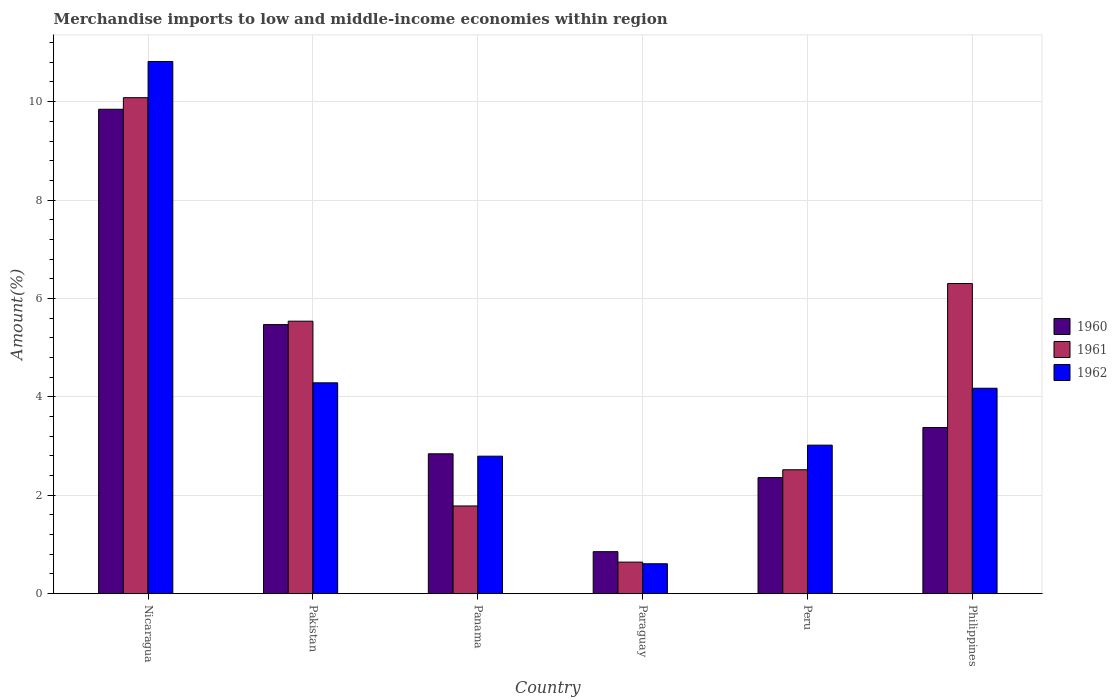How many groups of bars are there?
Your answer should be compact. 6. Are the number of bars per tick equal to the number of legend labels?
Give a very brief answer. Yes. How many bars are there on the 5th tick from the right?
Provide a short and direct response. 3. What is the label of the 2nd group of bars from the left?
Your answer should be compact. Pakistan. In how many cases, is the number of bars for a given country not equal to the number of legend labels?
Your response must be concise. 0. What is the percentage of amount earned from merchandise imports in 1961 in Peru?
Provide a succinct answer. 2.52. Across all countries, what is the maximum percentage of amount earned from merchandise imports in 1962?
Offer a terse response. 10.82. Across all countries, what is the minimum percentage of amount earned from merchandise imports in 1962?
Provide a succinct answer. 0.61. In which country was the percentage of amount earned from merchandise imports in 1961 maximum?
Ensure brevity in your answer.  Nicaragua. In which country was the percentage of amount earned from merchandise imports in 1960 minimum?
Give a very brief answer. Paraguay. What is the total percentage of amount earned from merchandise imports in 1960 in the graph?
Provide a short and direct response. 24.75. What is the difference between the percentage of amount earned from merchandise imports in 1962 in Panama and that in Paraguay?
Offer a terse response. 2.19. What is the difference between the percentage of amount earned from merchandise imports in 1962 in Peru and the percentage of amount earned from merchandise imports in 1961 in Paraguay?
Offer a very short reply. 2.38. What is the average percentage of amount earned from merchandise imports in 1962 per country?
Offer a very short reply. 4.28. What is the difference between the percentage of amount earned from merchandise imports of/in 1962 and percentage of amount earned from merchandise imports of/in 1961 in Nicaragua?
Your answer should be compact. 0.74. In how many countries, is the percentage of amount earned from merchandise imports in 1961 greater than 8.4 %?
Your answer should be very brief. 1. What is the ratio of the percentage of amount earned from merchandise imports in 1961 in Pakistan to that in Panama?
Provide a short and direct response. 3.11. Is the percentage of amount earned from merchandise imports in 1962 in Panama less than that in Peru?
Provide a short and direct response. Yes. What is the difference between the highest and the second highest percentage of amount earned from merchandise imports in 1961?
Provide a short and direct response. 4.54. What is the difference between the highest and the lowest percentage of amount earned from merchandise imports in 1961?
Keep it short and to the point. 9.44. In how many countries, is the percentage of amount earned from merchandise imports in 1960 greater than the average percentage of amount earned from merchandise imports in 1960 taken over all countries?
Keep it short and to the point. 2. Is the sum of the percentage of amount earned from merchandise imports in 1960 in Peru and Philippines greater than the maximum percentage of amount earned from merchandise imports in 1962 across all countries?
Offer a very short reply. No. What does the 1st bar from the right in Paraguay represents?
Your answer should be very brief. 1962. Is it the case that in every country, the sum of the percentage of amount earned from merchandise imports in 1961 and percentage of amount earned from merchandise imports in 1962 is greater than the percentage of amount earned from merchandise imports in 1960?
Offer a terse response. Yes. How many bars are there?
Your answer should be compact. 18. How many countries are there in the graph?
Keep it short and to the point. 6. What is the difference between two consecutive major ticks on the Y-axis?
Your answer should be very brief. 2. Are the values on the major ticks of Y-axis written in scientific E-notation?
Your response must be concise. No. Does the graph contain any zero values?
Provide a short and direct response. No. Does the graph contain grids?
Provide a short and direct response. Yes. Where does the legend appear in the graph?
Your answer should be compact. Center right. How many legend labels are there?
Provide a short and direct response. 3. How are the legend labels stacked?
Your response must be concise. Vertical. What is the title of the graph?
Ensure brevity in your answer.  Merchandise imports to low and middle-income economies within region. Does "1972" appear as one of the legend labels in the graph?
Your response must be concise. No. What is the label or title of the Y-axis?
Offer a terse response. Amount(%). What is the Amount(%) of 1960 in Nicaragua?
Provide a short and direct response. 9.85. What is the Amount(%) of 1961 in Nicaragua?
Offer a terse response. 10.08. What is the Amount(%) of 1962 in Nicaragua?
Your response must be concise. 10.82. What is the Amount(%) of 1960 in Pakistan?
Provide a succinct answer. 5.47. What is the Amount(%) of 1961 in Pakistan?
Ensure brevity in your answer.  5.54. What is the Amount(%) of 1962 in Pakistan?
Keep it short and to the point. 4.29. What is the Amount(%) of 1960 in Panama?
Your response must be concise. 2.84. What is the Amount(%) in 1961 in Panama?
Offer a very short reply. 1.78. What is the Amount(%) of 1962 in Panama?
Ensure brevity in your answer.  2.79. What is the Amount(%) in 1960 in Paraguay?
Keep it short and to the point. 0.85. What is the Amount(%) of 1961 in Paraguay?
Give a very brief answer. 0.64. What is the Amount(%) in 1962 in Paraguay?
Offer a terse response. 0.61. What is the Amount(%) of 1960 in Peru?
Offer a very short reply. 2.36. What is the Amount(%) in 1961 in Peru?
Ensure brevity in your answer.  2.52. What is the Amount(%) of 1962 in Peru?
Offer a very short reply. 3.02. What is the Amount(%) in 1960 in Philippines?
Provide a short and direct response. 3.38. What is the Amount(%) in 1961 in Philippines?
Ensure brevity in your answer.  6.3. What is the Amount(%) in 1962 in Philippines?
Make the answer very short. 4.18. Across all countries, what is the maximum Amount(%) of 1960?
Provide a short and direct response. 9.85. Across all countries, what is the maximum Amount(%) in 1961?
Provide a short and direct response. 10.08. Across all countries, what is the maximum Amount(%) in 1962?
Make the answer very short. 10.82. Across all countries, what is the minimum Amount(%) in 1960?
Ensure brevity in your answer.  0.85. Across all countries, what is the minimum Amount(%) in 1961?
Offer a very short reply. 0.64. Across all countries, what is the minimum Amount(%) in 1962?
Your answer should be very brief. 0.61. What is the total Amount(%) of 1960 in the graph?
Keep it short and to the point. 24.75. What is the total Amount(%) in 1961 in the graph?
Your answer should be very brief. 26.86. What is the total Amount(%) in 1962 in the graph?
Your response must be concise. 25.7. What is the difference between the Amount(%) of 1960 in Nicaragua and that in Pakistan?
Your answer should be compact. 4.38. What is the difference between the Amount(%) in 1961 in Nicaragua and that in Pakistan?
Ensure brevity in your answer.  4.54. What is the difference between the Amount(%) of 1962 in Nicaragua and that in Pakistan?
Offer a very short reply. 6.53. What is the difference between the Amount(%) of 1960 in Nicaragua and that in Panama?
Provide a short and direct response. 7. What is the difference between the Amount(%) in 1961 in Nicaragua and that in Panama?
Ensure brevity in your answer.  8.3. What is the difference between the Amount(%) of 1962 in Nicaragua and that in Panama?
Make the answer very short. 8.02. What is the difference between the Amount(%) in 1960 in Nicaragua and that in Paraguay?
Offer a terse response. 8.99. What is the difference between the Amount(%) of 1961 in Nicaragua and that in Paraguay?
Provide a succinct answer. 9.44. What is the difference between the Amount(%) of 1962 in Nicaragua and that in Paraguay?
Your answer should be very brief. 10.21. What is the difference between the Amount(%) in 1960 in Nicaragua and that in Peru?
Offer a very short reply. 7.49. What is the difference between the Amount(%) of 1961 in Nicaragua and that in Peru?
Offer a very short reply. 7.56. What is the difference between the Amount(%) in 1962 in Nicaragua and that in Peru?
Your response must be concise. 7.8. What is the difference between the Amount(%) of 1960 in Nicaragua and that in Philippines?
Provide a short and direct response. 6.47. What is the difference between the Amount(%) of 1961 in Nicaragua and that in Philippines?
Make the answer very short. 3.78. What is the difference between the Amount(%) of 1962 in Nicaragua and that in Philippines?
Provide a short and direct response. 6.64. What is the difference between the Amount(%) of 1960 in Pakistan and that in Panama?
Make the answer very short. 2.63. What is the difference between the Amount(%) in 1961 in Pakistan and that in Panama?
Ensure brevity in your answer.  3.76. What is the difference between the Amount(%) in 1962 in Pakistan and that in Panama?
Your answer should be compact. 1.49. What is the difference between the Amount(%) of 1960 in Pakistan and that in Paraguay?
Your answer should be very brief. 4.62. What is the difference between the Amount(%) in 1961 in Pakistan and that in Paraguay?
Give a very brief answer. 4.9. What is the difference between the Amount(%) in 1962 in Pakistan and that in Paraguay?
Provide a succinct answer. 3.68. What is the difference between the Amount(%) of 1960 in Pakistan and that in Peru?
Your answer should be very brief. 3.11. What is the difference between the Amount(%) of 1961 in Pakistan and that in Peru?
Ensure brevity in your answer.  3.02. What is the difference between the Amount(%) in 1962 in Pakistan and that in Peru?
Your answer should be compact. 1.27. What is the difference between the Amount(%) in 1960 in Pakistan and that in Philippines?
Your answer should be compact. 2.09. What is the difference between the Amount(%) of 1961 in Pakistan and that in Philippines?
Ensure brevity in your answer.  -0.76. What is the difference between the Amount(%) of 1962 in Pakistan and that in Philippines?
Ensure brevity in your answer.  0.11. What is the difference between the Amount(%) in 1960 in Panama and that in Paraguay?
Your answer should be compact. 1.99. What is the difference between the Amount(%) of 1961 in Panama and that in Paraguay?
Make the answer very short. 1.14. What is the difference between the Amount(%) in 1962 in Panama and that in Paraguay?
Your answer should be compact. 2.19. What is the difference between the Amount(%) of 1960 in Panama and that in Peru?
Offer a very short reply. 0.48. What is the difference between the Amount(%) of 1961 in Panama and that in Peru?
Your answer should be very brief. -0.74. What is the difference between the Amount(%) of 1962 in Panama and that in Peru?
Your response must be concise. -0.22. What is the difference between the Amount(%) in 1960 in Panama and that in Philippines?
Give a very brief answer. -0.53. What is the difference between the Amount(%) of 1961 in Panama and that in Philippines?
Offer a terse response. -4.52. What is the difference between the Amount(%) of 1962 in Panama and that in Philippines?
Your answer should be compact. -1.38. What is the difference between the Amount(%) in 1960 in Paraguay and that in Peru?
Provide a short and direct response. -1.51. What is the difference between the Amount(%) of 1961 in Paraguay and that in Peru?
Your response must be concise. -1.88. What is the difference between the Amount(%) in 1962 in Paraguay and that in Peru?
Your answer should be compact. -2.41. What is the difference between the Amount(%) in 1960 in Paraguay and that in Philippines?
Keep it short and to the point. -2.52. What is the difference between the Amount(%) in 1961 in Paraguay and that in Philippines?
Make the answer very short. -5.66. What is the difference between the Amount(%) in 1962 in Paraguay and that in Philippines?
Your answer should be very brief. -3.57. What is the difference between the Amount(%) of 1960 in Peru and that in Philippines?
Offer a very short reply. -1.02. What is the difference between the Amount(%) of 1961 in Peru and that in Philippines?
Give a very brief answer. -3.78. What is the difference between the Amount(%) in 1962 in Peru and that in Philippines?
Ensure brevity in your answer.  -1.16. What is the difference between the Amount(%) of 1960 in Nicaragua and the Amount(%) of 1961 in Pakistan?
Offer a very short reply. 4.31. What is the difference between the Amount(%) of 1960 in Nicaragua and the Amount(%) of 1962 in Pakistan?
Provide a succinct answer. 5.56. What is the difference between the Amount(%) of 1961 in Nicaragua and the Amount(%) of 1962 in Pakistan?
Your answer should be compact. 5.8. What is the difference between the Amount(%) in 1960 in Nicaragua and the Amount(%) in 1961 in Panama?
Give a very brief answer. 8.06. What is the difference between the Amount(%) of 1960 in Nicaragua and the Amount(%) of 1962 in Panama?
Offer a terse response. 7.05. What is the difference between the Amount(%) in 1961 in Nicaragua and the Amount(%) in 1962 in Panama?
Ensure brevity in your answer.  7.29. What is the difference between the Amount(%) in 1960 in Nicaragua and the Amount(%) in 1961 in Paraguay?
Provide a succinct answer. 9.2. What is the difference between the Amount(%) of 1960 in Nicaragua and the Amount(%) of 1962 in Paraguay?
Give a very brief answer. 9.24. What is the difference between the Amount(%) in 1961 in Nicaragua and the Amount(%) in 1962 in Paraguay?
Offer a terse response. 9.47. What is the difference between the Amount(%) of 1960 in Nicaragua and the Amount(%) of 1961 in Peru?
Keep it short and to the point. 7.33. What is the difference between the Amount(%) in 1960 in Nicaragua and the Amount(%) in 1962 in Peru?
Your answer should be very brief. 6.83. What is the difference between the Amount(%) in 1961 in Nicaragua and the Amount(%) in 1962 in Peru?
Provide a short and direct response. 7.06. What is the difference between the Amount(%) of 1960 in Nicaragua and the Amount(%) of 1961 in Philippines?
Ensure brevity in your answer.  3.54. What is the difference between the Amount(%) of 1960 in Nicaragua and the Amount(%) of 1962 in Philippines?
Offer a very short reply. 5.67. What is the difference between the Amount(%) of 1961 in Nicaragua and the Amount(%) of 1962 in Philippines?
Make the answer very short. 5.91. What is the difference between the Amount(%) of 1960 in Pakistan and the Amount(%) of 1961 in Panama?
Provide a short and direct response. 3.69. What is the difference between the Amount(%) of 1960 in Pakistan and the Amount(%) of 1962 in Panama?
Your answer should be compact. 2.67. What is the difference between the Amount(%) in 1961 in Pakistan and the Amount(%) in 1962 in Panama?
Ensure brevity in your answer.  2.74. What is the difference between the Amount(%) of 1960 in Pakistan and the Amount(%) of 1961 in Paraguay?
Your answer should be very brief. 4.83. What is the difference between the Amount(%) of 1960 in Pakistan and the Amount(%) of 1962 in Paraguay?
Make the answer very short. 4.86. What is the difference between the Amount(%) in 1961 in Pakistan and the Amount(%) in 1962 in Paraguay?
Offer a terse response. 4.93. What is the difference between the Amount(%) of 1960 in Pakistan and the Amount(%) of 1961 in Peru?
Give a very brief answer. 2.95. What is the difference between the Amount(%) in 1960 in Pakistan and the Amount(%) in 1962 in Peru?
Your answer should be compact. 2.45. What is the difference between the Amount(%) of 1961 in Pakistan and the Amount(%) of 1962 in Peru?
Make the answer very short. 2.52. What is the difference between the Amount(%) of 1960 in Pakistan and the Amount(%) of 1961 in Philippines?
Provide a succinct answer. -0.83. What is the difference between the Amount(%) of 1960 in Pakistan and the Amount(%) of 1962 in Philippines?
Offer a very short reply. 1.29. What is the difference between the Amount(%) in 1961 in Pakistan and the Amount(%) in 1962 in Philippines?
Offer a terse response. 1.36. What is the difference between the Amount(%) in 1960 in Panama and the Amount(%) in 1961 in Paraguay?
Give a very brief answer. 2.2. What is the difference between the Amount(%) in 1960 in Panama and the Amount(%) in 1962 in Paraguay?
Give a very brief answer. 2.23. What is the difference between the Amount(%) of 1961 in Panama and the Amount(%) of 1962 in Paraguay?
Offer a terse response. 1.17. What is the difference between the Amount(%) of 1960 in Panama and the Amount(%) of 1961 in Peru?
Offer a terse response. 0.32. What is the difference between the Amount(%) in 1960 in Panama and the Amount(%) in 1962 in Peru?
Your answer should be very brief. -0.18. What is the difference between the Amount(%) in 1961 in Panama and the Amount(%) in 1962 in Peru?
Make the answer very short. -1.24. What is the difference between the Amount(%) in 1960 in Panama and the Amount(%) in 1961 in Philippines?
Your answer should be very brief. -3.46. What is the difference between the Amount(%) of 1960 in Panama and the Amount(%) of 1962 in Philippines?
Keep it short and to the point. -1.33. What is the difference between the Amount(%) in 1961 in Panama and the Amount(%) in 1962 in Philippines?
Make the answer very short. -2.39. What is the difference between the Amount(%) of 1960 in Paraguay and the Amount(%) of 1961 in Peru?
Your answer should be very brief. -1.66. What is the difference between the Amount(%) of 1960 in Paraguay and the Amount(%) of 1962 in Peru?
Your answer should be very brief. -2.17. What is the difference between the Amount(%) in 1961 in Paraguay and the Amount(%) in 1962 in Peru?
Your answer should be compact. -2.38. What is the difference between the Amount(%) in 1960 in Paraguay and the Amount(%) in 1961 in Philippines?
Offer a terse response. -5.45. What is the difference between the Amount(%) in 1960 in Paraguay and the Amount(%) in 1962 in Philippines?
Give a very brief answer. -3.32. What is the difference between the Amount(%) of 1961 in Paraguay and the Amount(%) of 1962 in Philippines?
Your response must be concise. -3.53. What is the difference between the Amount(%) in 1960 in Peru and the Amount(%) in 1961 in Philippines?
Your answer should be very brief. -3.94. What is the difference between the Amount(%) of 1960 in Peru and the Amount(%) of 1962 in Philippines?
Your response must be concise. -1.82. What is the difference between the Amount(%) of 1961 in Peru and the Amount(%) of 1962 in Philippines?
Offer a very short reply. -1.66. What is the average Amount(%) in 1960 per country?
Make the answer very short. 4.12. What is the average Amount(%) of 1961 per country?
Ensure brevity in your answer.  4.48. What is the average Amount(%) of 1962 per country?
Offer a terse response. 4.28. What is the difference between the Amount(%) of 1960 and Amount(%) of 1961 in Nicaragua?
Your answer should be very brief. -0.24. What is the difference between the Amount(%) of 1960 and Amount(%) of 1962 in Nicaragua?
Your answer should be very brief. -0.97. What is the difference between the Amount(%) in 1961 and Amount(%) in 1962 in Nicaragua?
Provide a succinct answer. -0.74. What is the difference between the Amount(%) in 1960 and Amount(%) in 1961 in Pakistan?
Provide a succinct answer. -0.07. What is the difference between the Amount(%) in 1960 and Amount(%) in 1962 in Pakistan?
Provide a succinct answer. 1.18. What is the difference between the Amount(%) of 1961 and Amount(%) of 1962 in Pakistan?
Your answer should be very brief. 1.25. What is the difference between the Amount(%) in 1960 and Amount(%) in 1961 in Panama?
Offer a very short reply. 1.06. What is the difference between the Amount(%) in 1960 and Amount(%) in 1962 in Panama?
Offer a very short reply. 0.05. What is the difference between the Amount(%) in 1961 and Amount(%) in 1962 in Panama?
Offer a very short reply. -1.01. What is the difference between the Amount(%) of 1960 and Amount(%) of 1961 in Paraguay?
Offer a terse response. 0.21. What is the difference between the Amount(%) in 1960 and Amount(%) in 1962 in Paraguay?
Your response must be concise. 0.25. What is the difference between the Amount(%) in 1961 and Amount(%) in 1962 in Paraguay?
Keep it short and to the point. 0.03. What is the difference between the Amount(%) of 1960 and Amount(%) of 1961 in Peru?
Make the answer very short. -0.16. What is the difference between the Amount(%) in 1960 and Amount(%) in 1962 in Peru?
Provide a short and direct response. -0.66. What is the difference between the Amount(%) of 1961 and Amount(%) of 1962 in Peru?
Provide a succinct answer. -0.5. What is the difference between the Amount(%) of 1960 and Amount(%) of 1961 in Philippines?
Give a very brief answer. -2.93. What is the difference between the Amount(%) in 1960 and Amount(%) in 1962 in Philippines?
Your response must be concise. -0.8. What is the difference between the Amount(%) of 1961 and Amount(%) of 1962 in Philippines?
Provide a short and direct response. 2.13. What is the ratio of the Amount(%) of 1960 in Nicaragua to that in Pakistan?
Your response must be concise. 1.8. What is the ratio of the Amount(%) in 1961 in Nicaragua to that in Pakistan?
Provide a short and direct response. 1.82. What is the ratio of the Amount(%) in 1962 in Nicaragua to that in Pakistan?
Your response must be concise. 2.52. What is the ratio of the Amount(%) of 1960 in Nicaragua to that in Panama?
Your answer should be very brief. 3.46. What is the ratio of the Amount(%) of 1961 in Nicaragua to that in Panama?
Your answer should be very brief. 5.66. What is the ratio of the Amount(%) in 1962 in Nicaragua to that in Panama?
Offer a terse response. 3.87. What is the ratio of the Amount(%) in 1960 in Nicaragua to that in Paraguay?
Ensure brevity in your answer.  11.54. What is the ratio of the Amount(%) of 1961 in Nicaragua to that in Paraguay?
Make the answer very short. 15.72. What is the ratio of the Amount(%) of 1962 in Nicaragua to that in Paraguay?
Make the answer very short. 17.8. What is the ratio of the Amount(%) of 1960 in Nicaragua to that in Peru?
Provide a short and direct response. 4.17. What is the ratio of the Amount(%) in 1961 in Nicaragua to that in Peru?
Offer a very short reply. 4. What is the ratio of the Amount(%) of 1962 in Nicaragua to that in Peru?
Ensure brevity in your answer.  3.58. What is the ratio of the Amount(%) of 1960 in Nicaragua to that in Philippines?
Offer a terse response. 2.92. What is the ratio of the Amount(%) in 1961 in Nicaragua to that in Philippines?
Offer a terse response. 1.6. What is the ratio of the Amount(%) in 1962 in Nicaragua to that in Philippines?
Your answer should be compact. 2.59. What is the ratio of the Amount(%) in 1960 in Pakistan to that in Panama?
Ensure brevity in your answer.  1.92. What is the ratio of the Amount(%) in 1961 in Pakistan to that in Panama?
Make the answer very short. 3.11. What is the ratio of the Amount(%) in 1962 in Pakistan to that in Panama?
Offer a terse response. 1.53. What is the ratio of the Amount(%) of 1960 in Pakistan to that in Paraguay?
Your response must be concise. 6.41. What is the ratio of the Amount(%) in 1961 in Pakistan to that in Paraguay?
Make the answer very short. 8.64. What is the ratio of the Amount(%) in 1962 in Pakistan to that in Paraguay?
Your response must be concise. 7.05. What is the ratio of the Amount(%) in 1960 in Pakistan to that in Peru?
Make the answer very short. 2.32. What is the ratio of the Amount(%) of 1961 in Pakistan to that in Peru?
Provide a short and direct response. 2.2. What is the ratio of the Amount(%) of 1962 in Pakistan to that in Peru?
Offer a very short reply. 1.42. What is the ratio of the Amount(%) of 1960 in Pakistan to that in Philippines?
Keep it short and to the point. 1.62. What is the ratio of the Amount(%) in 1961 in Pakistan to that in Philippines?
Offer a terse response. 0.88. What is the ratio of the Amount(%) of 1962 in Pakistan to that in Philippines?
Keep it short and to the point. 1.03. What is the ratio of the Amount(%) of 1960 in Panama to that in Paraguay?
Your answer should be compact. 3.33. What is the ratio of the Amount(%) of 1961 in Panama to that in Paraguay?
Your response must be concise. 2.78. What is the ratio of the Amount(%) in 1962 in Panama to that in Paraguay?
Offer a terse response. 4.6. What is the ratio of the Amount(%) in 1960 in Panama to that in Peru?
Ensure brevity in your answer.  1.2. What is the ratio of the Amount(%) of 1961 in Panama to that in Peru?
Offer a terse response. 0.71. What is the ratio of the Amount(%) of 1962 in Panama to that in Peru?
Ensure brevity in your answer.  0.93. What is the ratio of the Amount(%) of 1960 in Panama to that in Philippines?
Offer a terse response. 0.84. What is the ratio of the Amount(%) of 1961 in Panama to that in Philippines?
Your response must be concise. 0.28. What is the ratio of the Amount(%) in 1962 in Panama to that in Philippines?
Your answer should be very brief. 0.67. What is the ratio of the Amount(%) in 1960 in Paraguay to that in Peru?
Your response must be concise. 0.36. What is the ratio of the Amount(%) in 1961 in Paraguay to that in Peru?
Provide a succinct answer. 0.25. What is the ratio of the Amount(%) of 1962 in Paraguay to that in Peru?
Give a very brief answer. 0.2. What is the ratio of the Amount(%) of 1960 in Paraguay to that in Philippines?
Make the answer very short. 0.25. What is the ratio of the Amount(%) in 1961 in Paraguay to that in Philippines?
Keep it short and to the point. 0.1. What is the ratio of the Amount(%) of 1962 in Paraguay to that in Philippines?
Give a very brief answer. 0.15. What is the ratio of the Amount(%) in 1960 in Peru to that in Philippines?
Offer a very short reply. 0.7. What is the ratio of the Amount(%) of 1961 in Peru to that in Philippines?
Your answer should be compact. 0.4. What is the ratio of the Amount(%) of 1962 in Peru to that in Philippines?
Provide a succinct answer. 0.72. What is the difference between the highest and the second highest Amount(%) in 1960?
Offer a very short reply. 4.38. What is the difference between the highest and the second highest Amount(%) of 1961?
Provide a short and direct response. 3.78. What is the difference between the highest and the second highest Amount(%) in 1962?
Make the answer very short. 6.53. What is the difference between the highest and the lowest Amount(%) in 1960?
Ensure brevity in your answer.  8.99. What is the difference between the highest and the lowest Amount(%) of 1961?
Your answer should be very brief. 9.44. What is the difference between the highest and the lowest Amount(%) in 1962?
Make the answer very short. 10.21. 